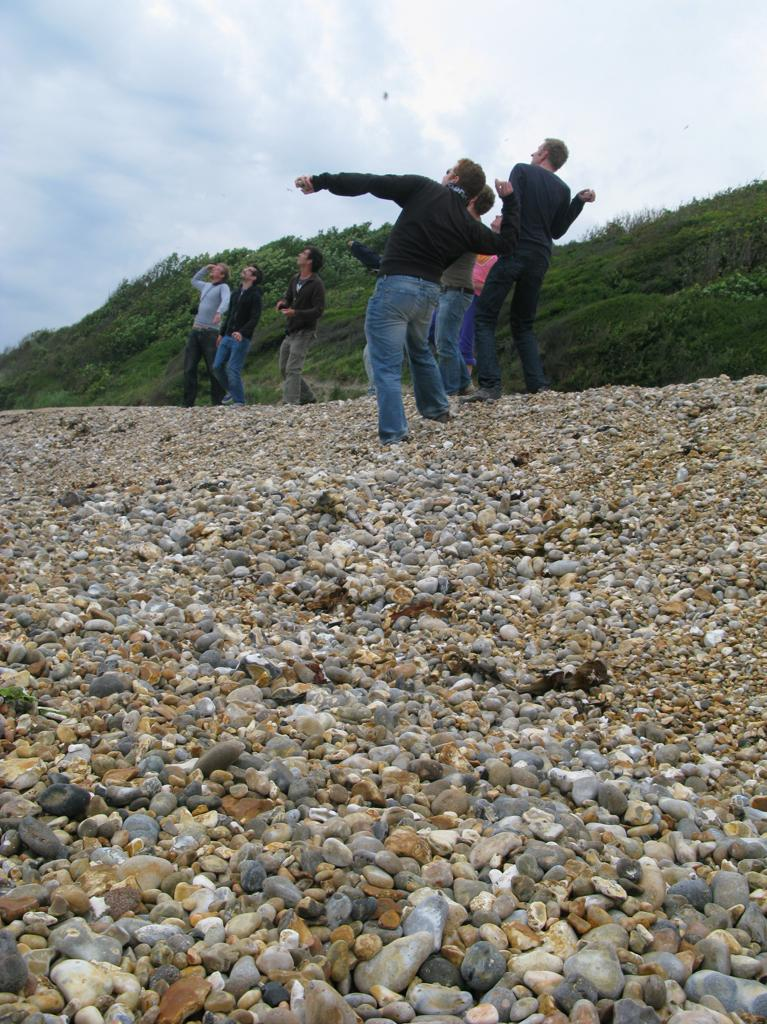Who or what can be seen in the image? There are people in the image. What objects are present in the image? There are stones in the image. What can be seen in the background of the image? There is grass, plants, and the sky visible in the background of the image. What is the condition of the sky in the image? Clouds are present in the sky. Where is the kitten hiding in the image? There is no kitten present in the image. What is the spot on the grass used for in the image? There is no spot on the grass mentioned in the image; it only states that there is grass in the background. 